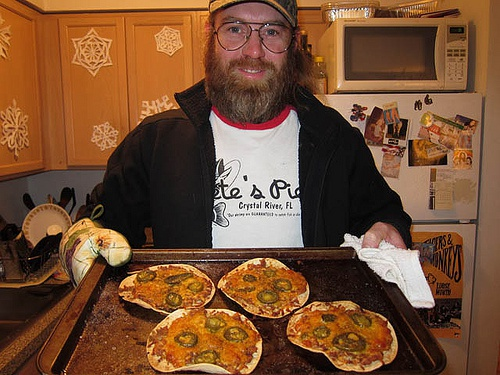Describe the objects in this image and their specific colors. I can see people in red, black, lightgray, maroon, and brown tones, refrigerator in red, gray, tan, maroon, and black tones, microwave in red, maroon, brown, black, and gray tones, pizza in red, orange, and tan tones, and pizza in red, brown, maroon, and tan tones in this image. 